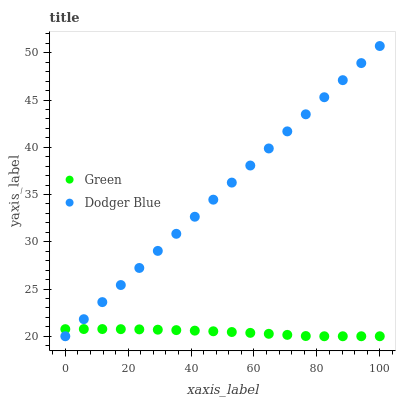Does Green have the minimum area under the curve?
Answer yes or no. Yes. Does Dodger Blue have the maximum area under the curve?
Answer yes or no. Yes. Does Green have the maximum area under the curve?
Answer yes or no. No. Is Dodger Blue the smoothest?
Answer yes or no. Yes. Is Green the roughest?
Answer yes or no. Yes. Is Green the smoothest?
Answer yes or no. No. Does Dodger Blue have the lowest value?
Answer yes or no. Yes. Does Dodger Blue have the highest value?
Answer yes or no. Yes. Does Green have the highest value?
Answer yes or no. No. Does Dodger Blue intersect Green?
Answer yes or no. Yes. Is Dodger Blue less than Green?
Answer yes or no. No. Is Dodger Blue greater than Green?
Answer yes or no. No. 